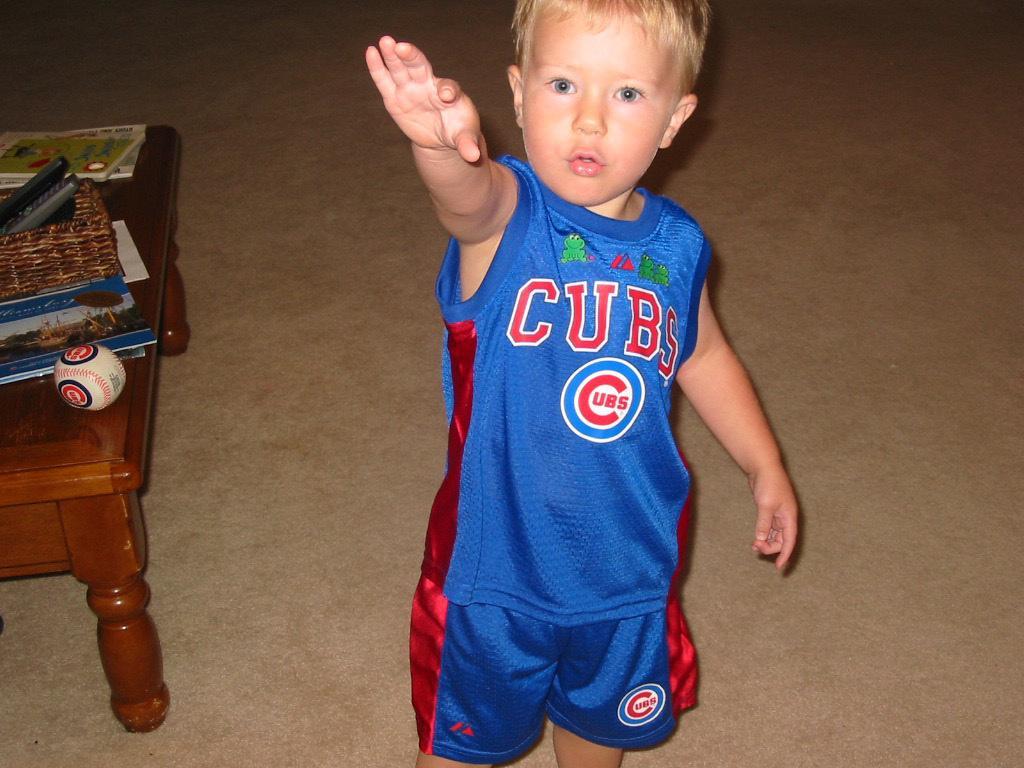Please provide a concise description of this image. There is a boy in the picture who is wearing a red, blue shirt and short and beside him there is a table on which there is a book and a ball and the boy is raising his right hand. 